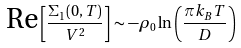<formula> <loc_0><loc_0><loc_500><loc_500>\text {Re} \left [ \frac { \Sigma _ { 1 } ( 0 , T ) } { V ^ { 2 } } \right ] \sim - \rho _ { 0 } \ln \left ( \frac { \pi k _ { B } T } { D } \right )</formula> 